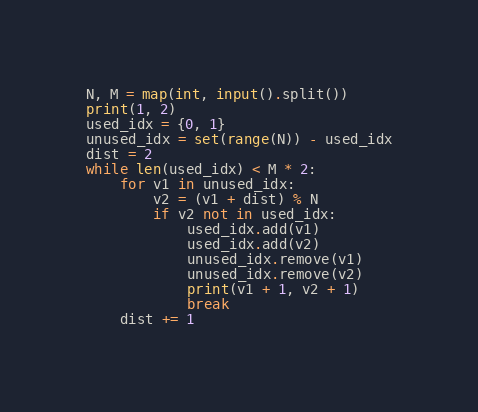<code> <loc_0><loc_0><loc_500><loc_500><_Python_>N, M = map(int, input().split())
print(1, 2)
used_idx = {0, 1}
unused_idx = set(range(N)) - used_idx
dist = 2
while len(used_idx) < M * 2:
    for v1 in unused_idx:
        v2 = (v1 + dist) % N
        if v2 not in used_idx:
            used_idx.add(v1)
            used_idx.add(v2)
            unused_idx.remove(v1)
            unused_idx.remove(v2)
            print(v1 + 1, v2 + 1)
            break
    dist += 1</code> 